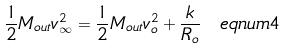Convert formula to latex. <formula><loc_0><loc_0><loc_500><loc_500>\frac { 1 } { 2 } M _ { o u t } v _ { \infty } ^ { 2 } = \frac { 1 } { 2 } M _ { o u t } v _ { o } ^ { 2 } + \frac { k } { R _ { o } } \ e q n u m { 4 }</formula> 